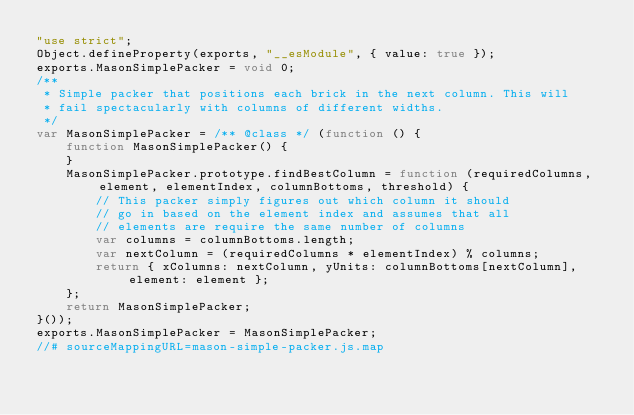Convert code to text. <code><loc_0><loc_0><loc_500><loc_500><_JavaScript_>"use strict";
Object.defineProperty(exports, "__esModule", { value: true });
exports.MasonSimplePacker = void 0;
/**
 * Simple packer that positions each brick in the next column. This will
 * fail spectacularly with columns of different widths.
 */
var MasonSimplePacker = /** @class */ (function () {
    function MasonSimplePacker() {
    }
    MasonSimplePacker.prototype.findBestColumn = function (requiredColumns, element, elementIndex, columnBottoms, threshold) {
        // This packer simply figures out which column it should
        // go in based on the element index and assumes that all
        // elements are require the same number of columns
        var columns = columnBottoms.length;
        var nextColumn = (requiredColumns * elementIndex) % columns;
        return { xColumns: nextColumn, yUnits: columnBottoms[nextColumn], element: element };
    };
    return MasonSimplePacker;
}());
exports.MasonSimplePacker = MasonSimplePacker;
//# sourceMappingURL=mason-simple-packer.js.map</code> 